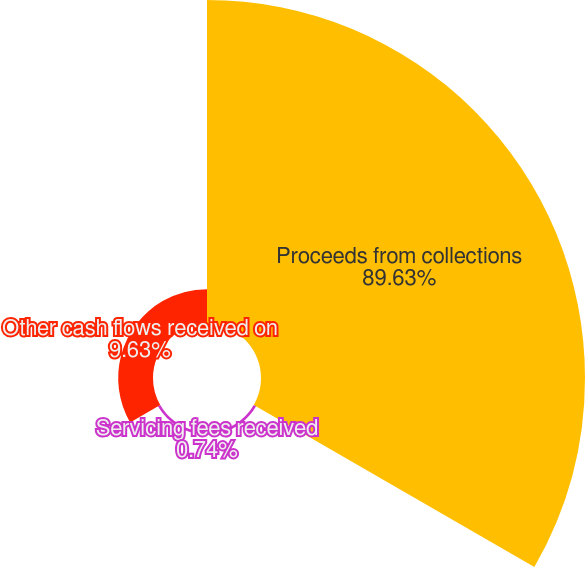Convert chart to OTSL. <chart><loc_0><loc_0><loc_500><loc_500><pie_chart><fcel>Proceeds from collections<fcel>Servicing fees received<fcel>Other cash flows received on<nl><fcel>89.63%<fcel>0.74%<fcel>9.63%<nl></chart> 